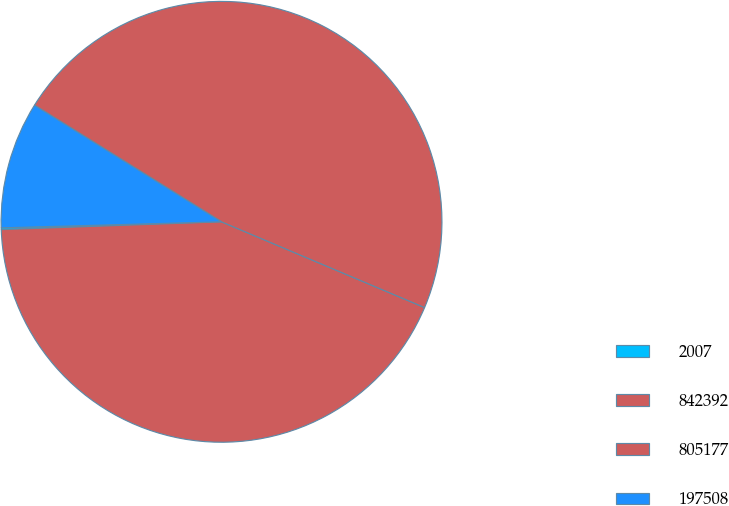Convert chart. <chart><loc_0><loc_0><loc_500><loc_500><pie_chart><fcel>2007<fcel>842392<fcel>805177<fcel>197508<nl><fcel>0.13%<fcel>43.08%<fcel>47.49%<fcel>9.31%<nl></chart> 